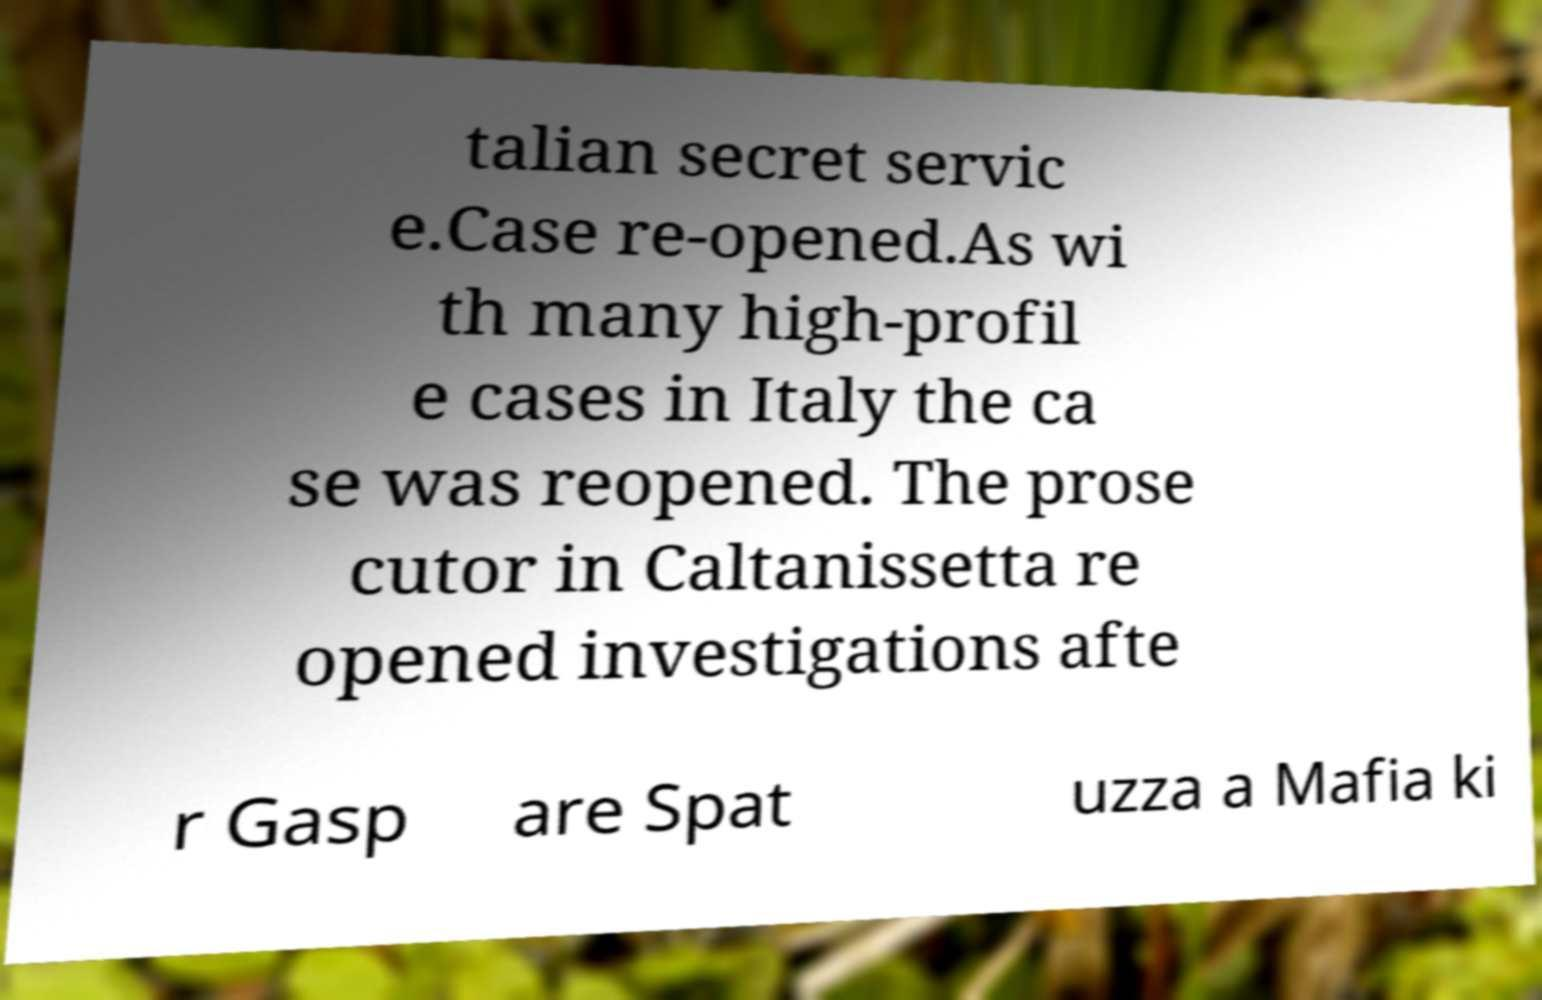Can you accurately transcribe the text from the provided image for me? talian secret servic e.Case re-opened.As wi th many high-profil e cases in Italy the ca se was reopened. The prose cutor in Caltanissetta re opened investigations afte r Gasp are Spat uzza a Mafia ki 